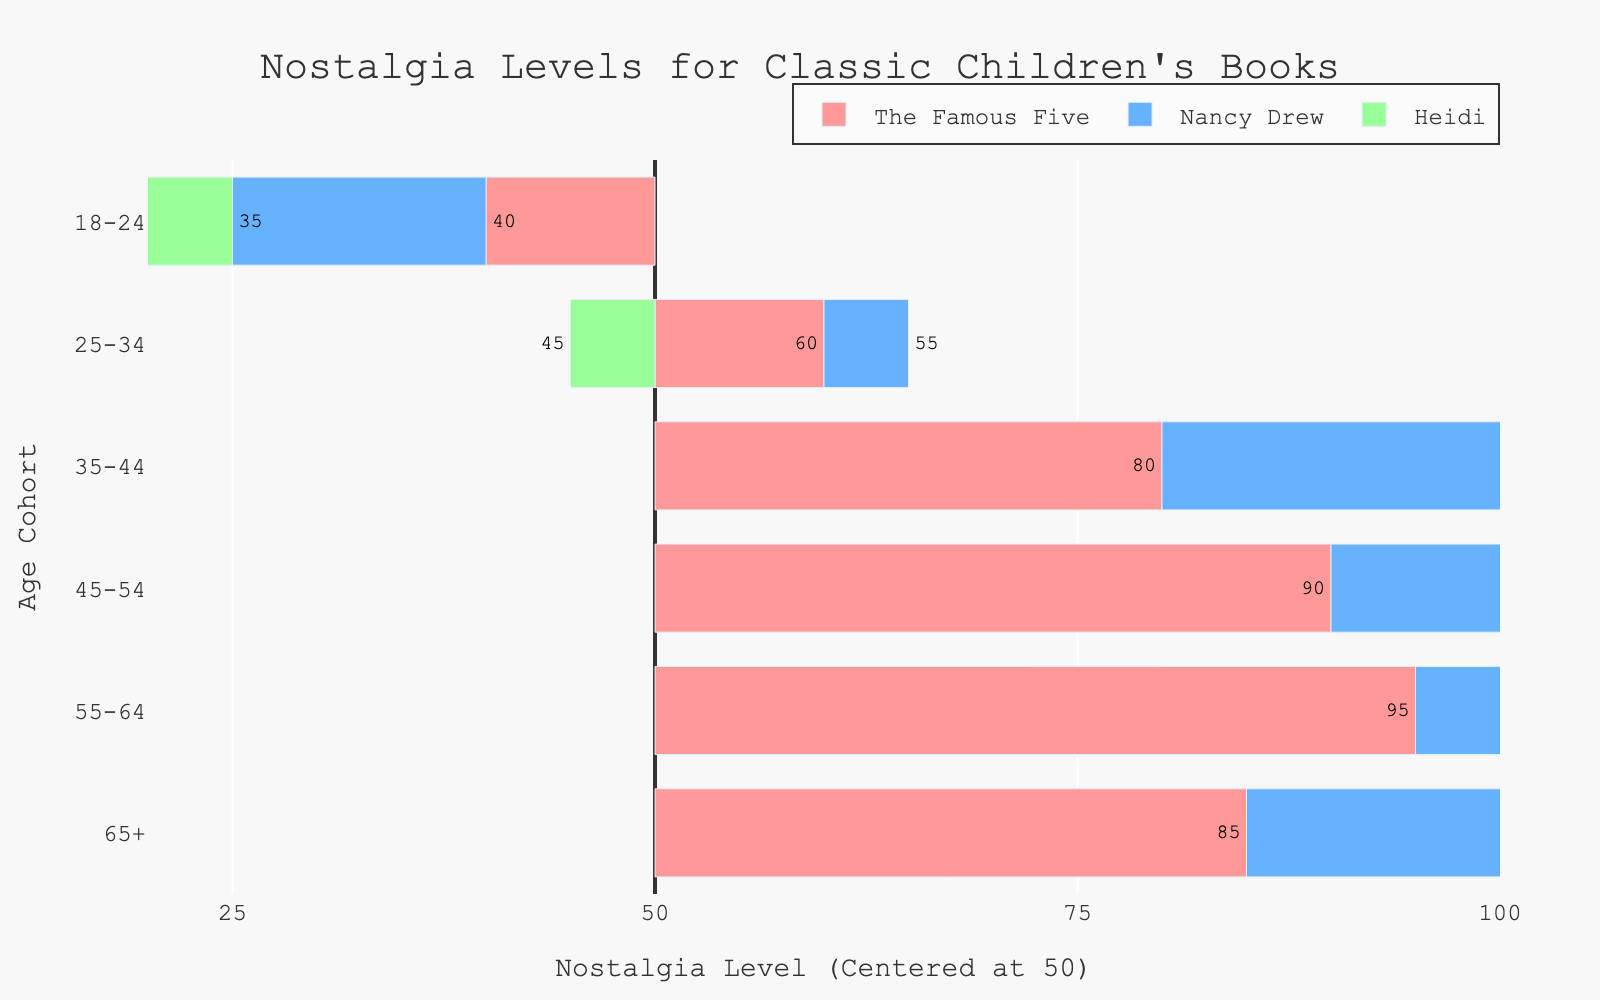What age cohort has the highest nostalgia level for "The Famous Five"? Referring to the plot, the 55-64 age cohort shows the highest nostalgia level for "The Famous Five" as their bar extends furthest to the right.
Answer: 55-64 Which book has the highest nostalgia level among the 45-54 age cohort? For the 45-54 age cohort, "The Famous Five" has the highest nostalgia level, as its bar extends further to the right compared to "Nancy Drew" and "Heidi".
Answer: The Famous Five By how much does the nostalgia level for "Nancy Drew" differ between the 18-24 and 35-44 age cohorts? The nostalgia level for "Nancy Drew" in the 18-24 cohort is 35, and in the 35-44 cohort, it's 75. The difference is 75 - 35 = 40.
Answer: 40 What is the average nostalgia level for "Heidi" across all age cohorts? Summing the nostalgia levels of "Heidi" for each cohort (25 + 45 + 65 + 70 + 75 + 80 = 360) and then dividing by the number of cohorts (6), we get 360 / 6 = 60.
Answer: 60 Which age cohort has the lowest nostalgia level for "The Famous Five"? Observing the chart, the 18-24 age cohort has the lowest nostalgia level for "The Famous Five" because its bar extends the least to the right.
Answer: 18-24 Among the 65+ age cohort, which book has the highest nostalgia level? For the 65+ age cohort, "Heidi" has the highest nostalgia level, as its bar is the longest to the right.
Answer: Heidi How many age cohorts have a nostalgia level of 75 or higher for "Nancy Drew"? The age cohorts with 75 or higher nostalgia levels for "Nancy Drew" are 35-44 (75), 45-54 (85), and 55-64 (80). That makes 3 cohorts.
Answer: 3 Do the nostalgia levels for "Heidi" consistently increase as the age cohorts get older? Examining the bars for "Heidi", the nostalgia levels are 25 (18-24), 45 (25-34), 65 (35-44), 70 (45-54), 75 (55-64), and 80 (65+), which consistently increase, confirming an increasing trend.
Answer: Yes 